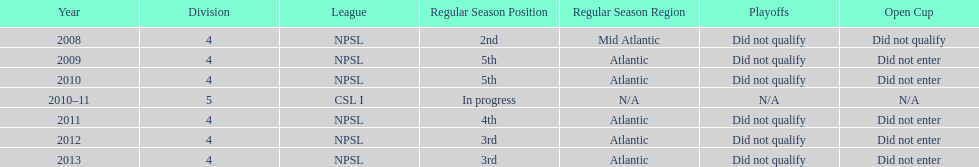How did they place the year after they were 4th in the regular season? 3rd. 